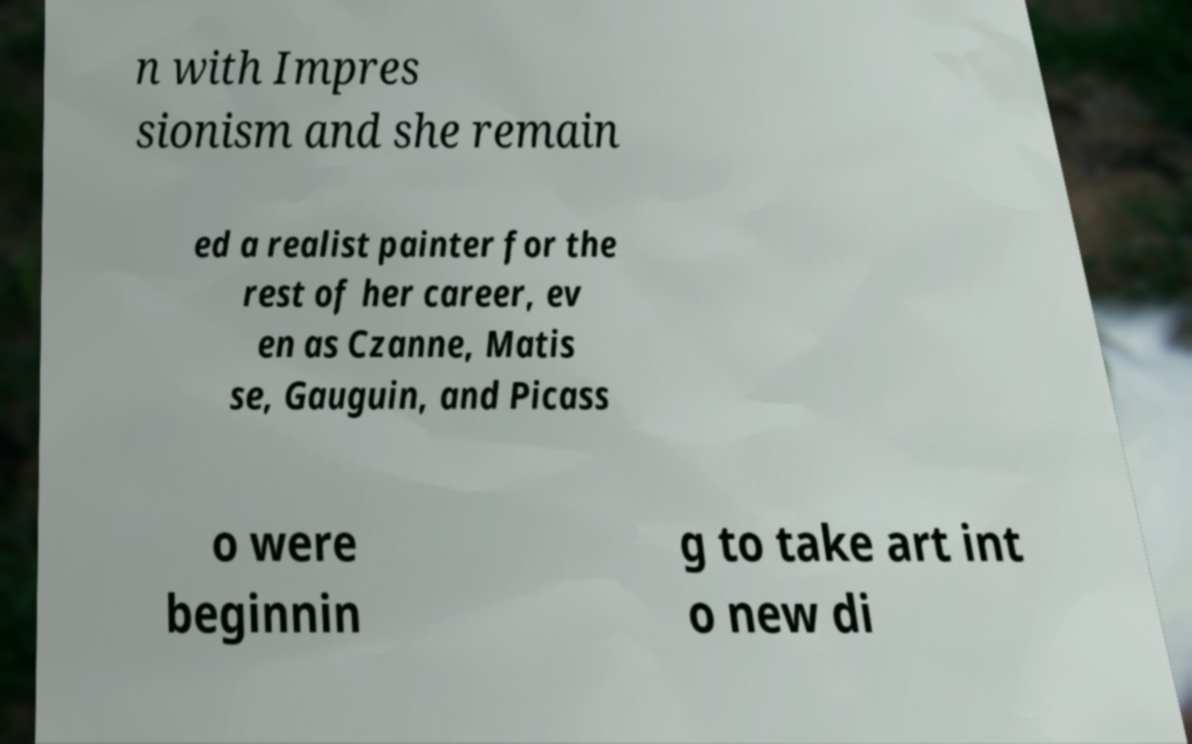For documentation purposes, I need the text within this image transcribed. Could you provide that? n with Impres sionism and she remain ed a realist painter for the rest of her career, ev en as Czanne, Matis se, Gauguin, and Picass o were beginnin g to take art int o new di 